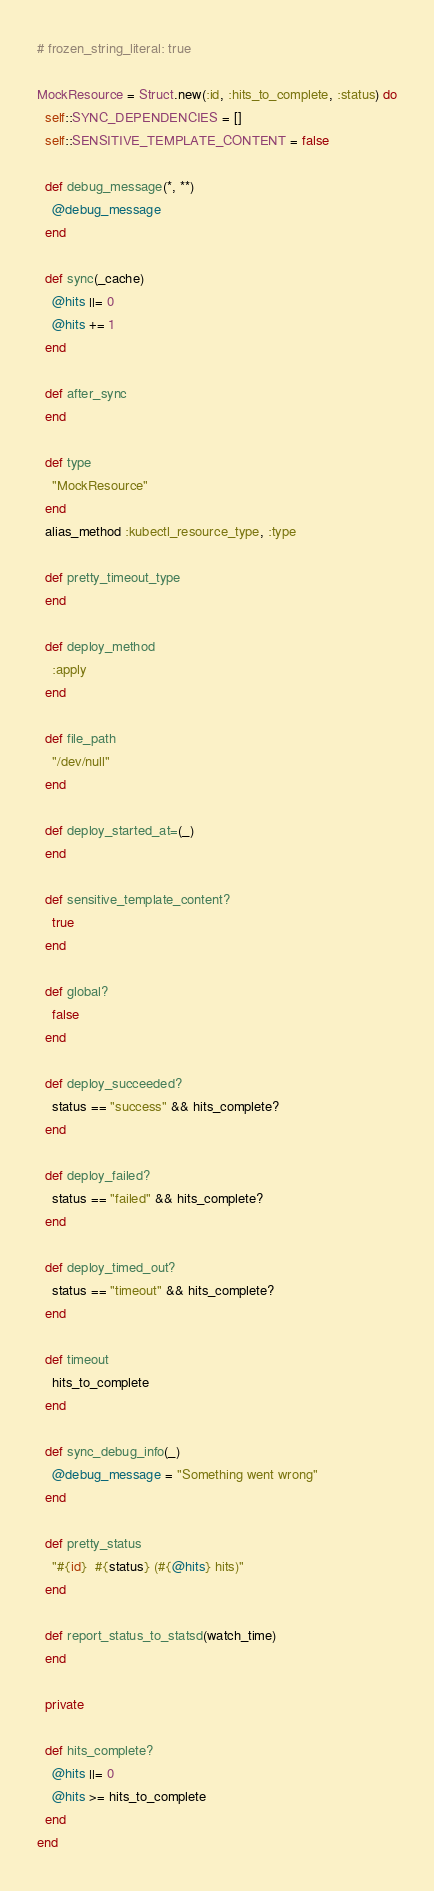Convert code to text. <code><loc_0><loc_0><loc_500><loc_500><_Ruby_># frozen_string_literal: true

MockResource = Struct.new(:id, :hits_to_complete, :status) do
  self::SYNC_DEPENDENCIES = []
  self::SENSITIVE_TEMPLATE_CONTENT = false

  def debug_message(*, **)
    @debug_message
  end

  def sync(_cache)
    @hits ||= 0
    @hits += 1
  end

  def after_sync
  end

  def type
    "MockResource"
  end
  alias_method :kubectl_resource_type, :type

  def pretty_timeout_type
  end

  def deploy_method
    :apply
  end

  def file_path
    "/dev/null"
  end

  def deploy_started_at=(_)
  end

  def sensitive_template_content?
    true
  end

  def global?
    false
  end

  def deploy_succeeded?
    status == "success" && hits_complete?
  end

  def deploy_failed?
    status == "failed" && hits_complete?
  end

  def deploy_timed_out?
    status == "timeout" && hits_complete?
  end

  def timeout
    hits_to_complete
  end

  def sync_debug_info(_)
    @debug_message = "Something went wrong"
  end

  def pretty_status
    "#{id}  #{status} (#{@hits} hits)"
  end

  def report_status_to_statsd(watch_time)
  end

  private

  def hits_complete?
    @hits ||= 0
    @hits >= hits_to_complete
  end
end
</code> 